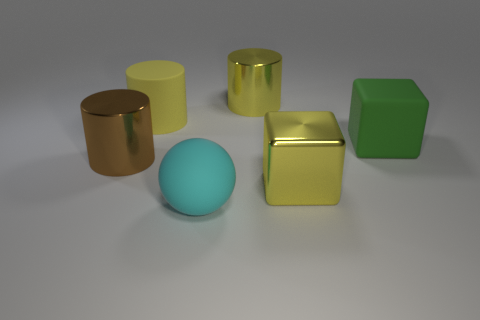Can you tell me more about the lighting in the scene? The lighting in the scene is soft and diffused, coming from the upper front, as indicated by the gentle shadows cast behind the objects. This lighting helps to accentuate the shapes and textures of the objects without creating harsh reflections. 